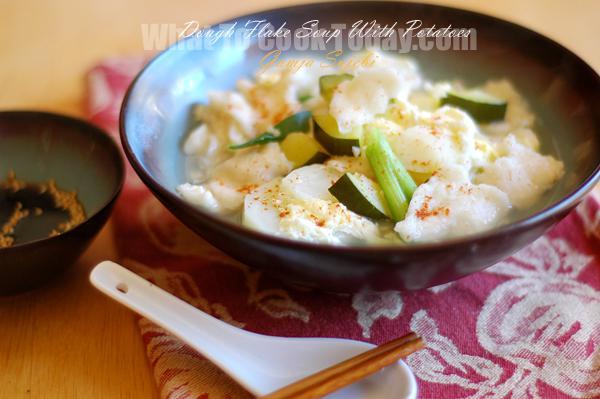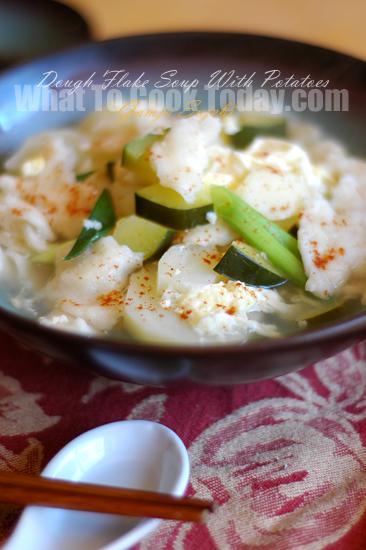The first image is the image on the left, the second image is the image on the right. Evaluate the accuracy of this statement regarding the images: "A metal spoon is over a round container of broth and other ingredients in one image.". Is it true? Answer yes or no. No. The first image is the image on the left, the second image is the image on the right. For the images shown, is this caption "There is a single white bowl in the left image." true? Answer yes or no. No. 